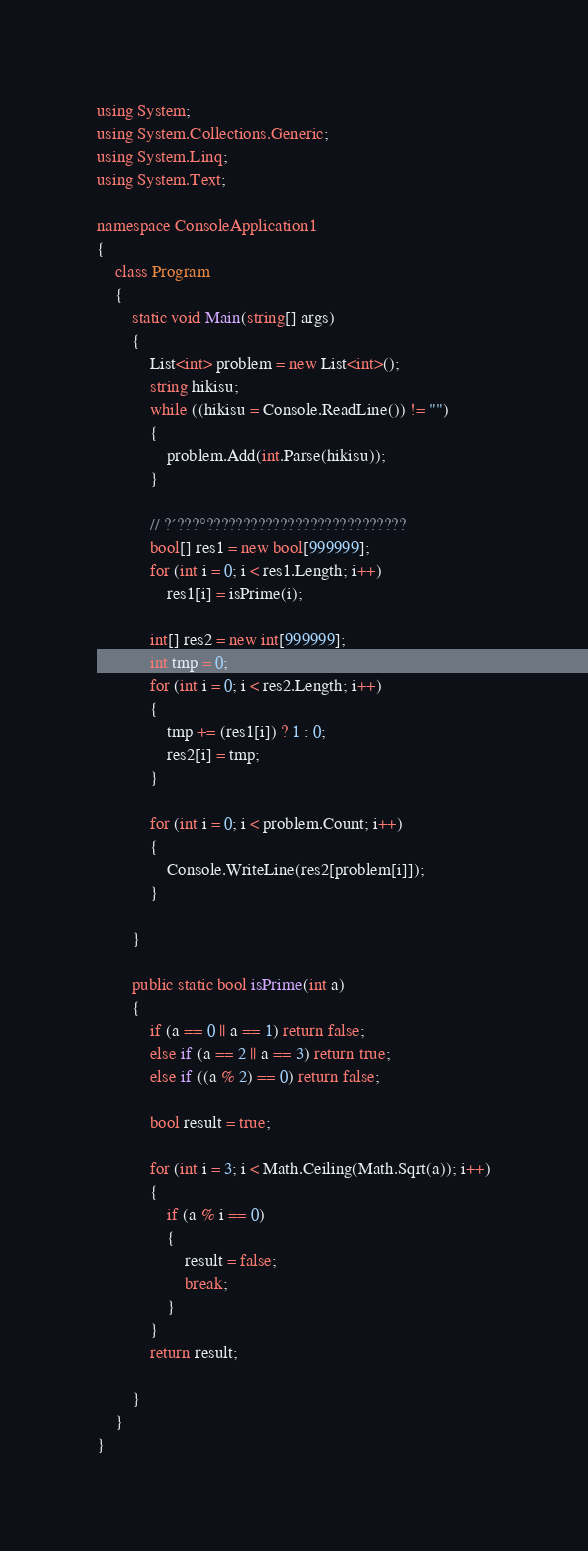Convert code to text. <code><loc_0><loc_0><loc_500><loc_500><_C#_>using System;
using System.Collections.Generic;
using System.Linq;
using System.Text;

namespace ConsoleApplication1
{
    class Program
    {
        static void Main(string[] args)
        {
            List<int> problem = new List<int>();
            string hikisu;
            while ((hikisu = Console.ReadLine()) != "")
            {
                problem.Add(int.Parse(hikisu));
            }

            // ?´???°???????????????????????????
            bool[] res1 = new bool[999999];
            for (int i = 0; i < res1.Length; i++)
                res1[i] = isPrime(i);

            int[] res2 = new int[999999];
            int tmp = 0;
            for (int i = 0; i < res2.Length; i++)
            {
                tmp += (res1[i]) ? 1 : 0;
                res2[i] = tmp;
            }

            for (int i = 0; i < problem.Count; i++)
            {
                Console.WriteLine(res2[problem[i]]);
            }
            
        }

        public static bool isPrime(int a)
        {
            if (a == 0 || a == 1) return false;
            else if (a == 2 || a == 3) return true;
            else if ((a % 2) == 0) return false;

            bool result = true;

            for (int i = 3; i < Math.Ceiling(Math.Sqrt(a)); i++)
            {
                if (a % i == 0)
                {
                    result = false;
                    break;
                }
            }
            return result;

        }
    }
}</code> 